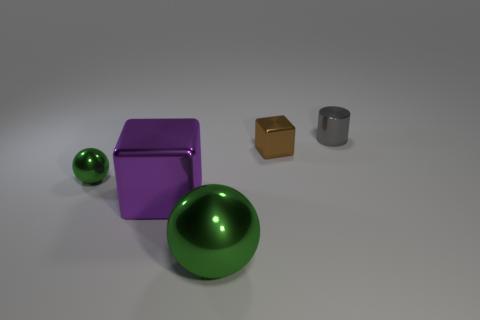Do the block that is behind the small green shiny ball and the green thing in front of the small metal ball have the same material?
Your answer should be compact. Yes. How many other metal balls have the same color as the tiny sphere?
Offer a very short reply. 1. What is the shape of the metallic thing that is both behind the large purple metal object and left of the brown object?
Your response must be concise. Sphere. The tiny thing that is both to the left of the gray thing and on the right side of the large green metallic ball is what color?
Ensure brevity in your answer.  Brown. Are there more small objects in front of the gray cylinder than green metallic spheres behind the large green thing?
Provide a short and direct response. Yes. What color is the block to the right of the large green thing?
Provide a succinct answer. Brown. Does the thing that is on the right side of the tiny brown metal cube have the same shape as the green object in front of the small green metallic ball?
Make the answer very short. No. Is there a brown matte cube that has the same size as the brown object?
Ensure brevity in your answer.  No. What material is the cube that is in front of the brown metallic cube?
Your answer should be very brief. Metal. Is the green thing that is right of the purple block made of the same material as the tiny brown block?
Provide a short and direct response. Yes. 